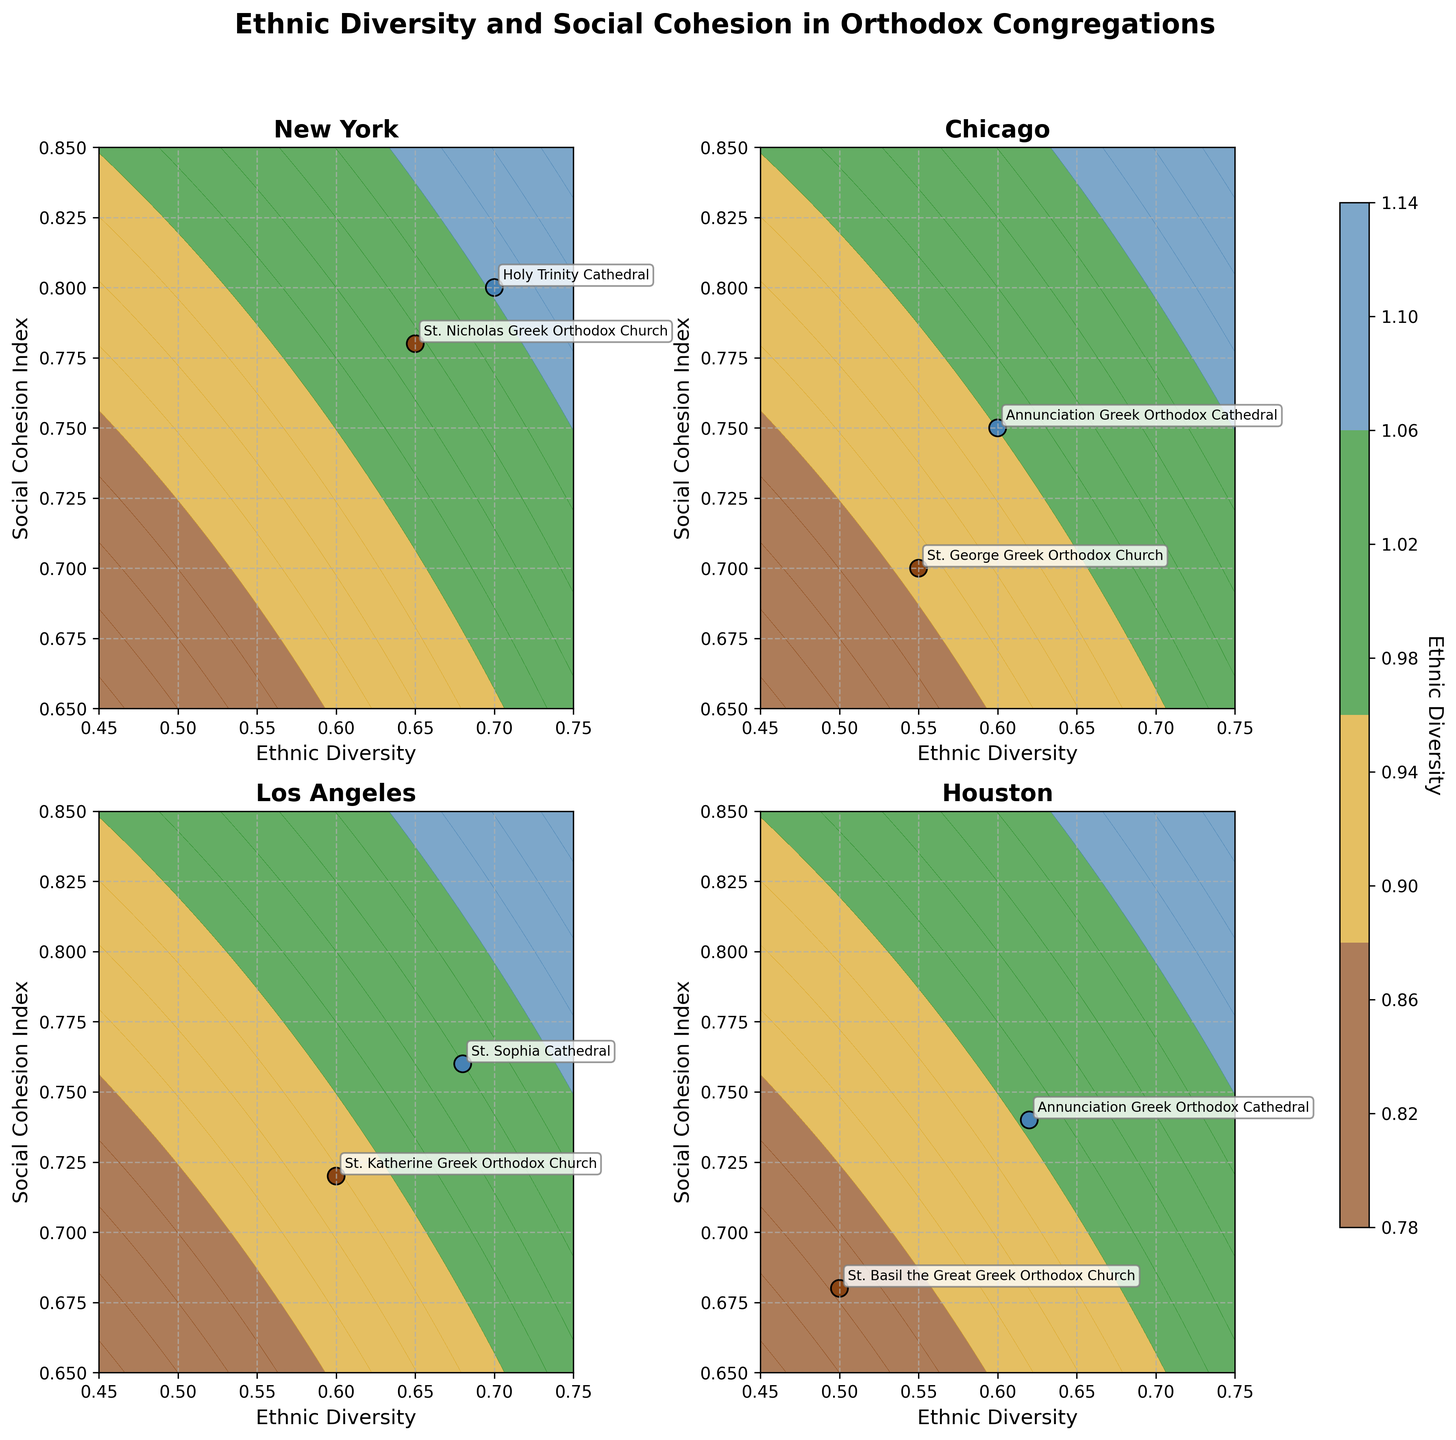What's the title of the figure? The title is displayed at the top of the figure. It is clearly mentioned as 'Ethnic Diversity and Social Cohesion in Orthodox Congregations'.
Answer: Ethnic Diversity and Social Cohesion in Orthodox Congregations What is the range of the Ethnic Diversity axis? The range can be inferred from the x-axis of the subplots, which spans from the minimum to the maximum data points provided, 0.45 to 0.75.
Answer: 0.45 to 0.75 Which city has the highest ethnic diversity value, and what is that value? We need to look at each subplot and identify the highest ethnic diversity value marked. For instance, New York has a point at 0.70.
Answer: New York, 0.70 In the New York subplot, which congregation has the highest social cohesion index? By checking the plot points and their corresponding annotations in the New York subplot, the highest value on the y-axis (social cohesion index) can be found at the annotated point 'Holy Trinity Cathedral'.
Answer: Holy Trinity Cathedral (0.80) How does the social cohesion index for Houston's congregations compare to that of Los Angeles's? Comparing the scatter points of the two cities, the highest social cohesion index in Houston is 0.74, while in Los Angeles it is 0.76. Thus, Los Angeles generally has a slightly higher social cohesion index.
Answer: Los Angeles's social cohesion index is slightly higher than Houston's Which subplot shows the lowest ethnic diversity among all congregations, and what is the value? By identifying the point with the lowest ethnic diversity in all subplots, the Houston subplot has the lowest value at 0.50 (St. Basil the Great Greek Orthodox Church).
Answer: Houston, 0.50 On average, do cities with higher ethnic diversity also have higher social cohesion indices? By inspecting the subplots and roughly averaging the scatter points, cities with higher ethnic diversity values, like New York and Boston, also appear to have higher social cohesion indices.
Answer: Yes Which congregation in Atlanta has a higher social cohesion index, and what is the difference between them? Comparing the two annotated points in Atlanta's subplot, 'Annunciation Cathedral' has a higher index at 0.73 compared to 'Holy Transfiguration' at 0.71. The difference is 0.02.
Answer: Annunciation Cathedral, difference of 0.02 